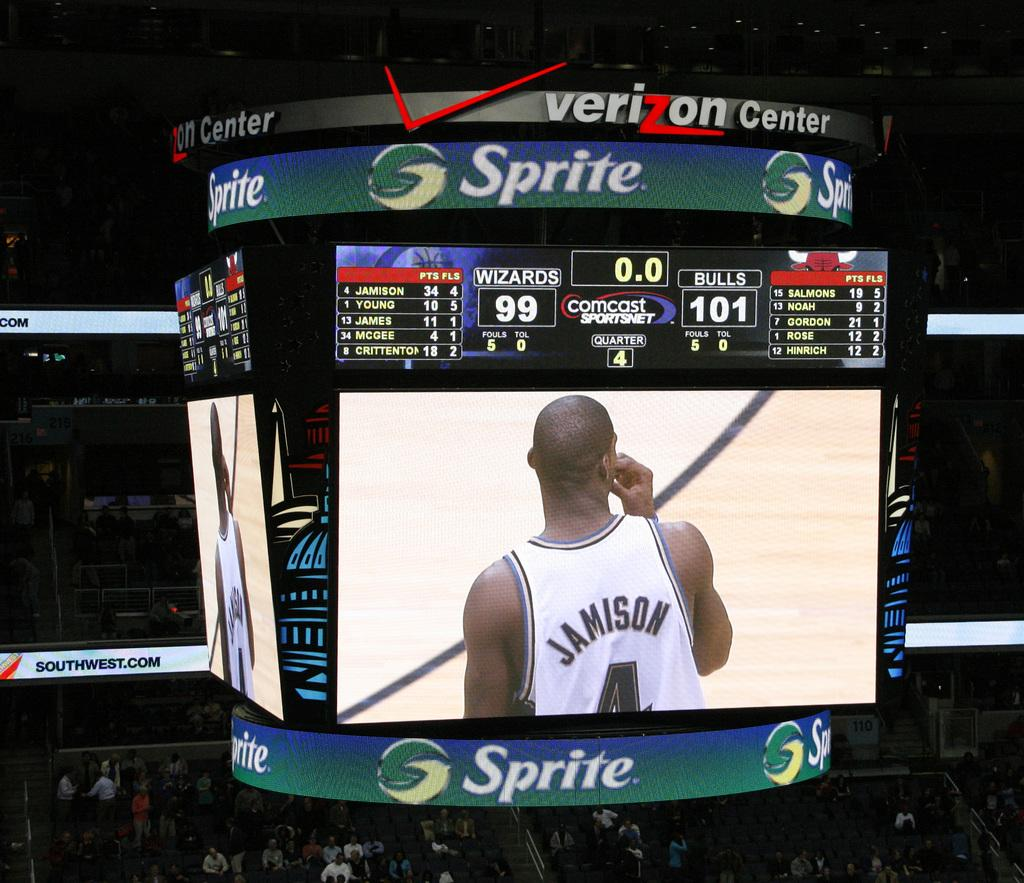<image>
Share a concise interpretation of the image provided. A Jumbotron at the Verizon Center showing player Jamison. 